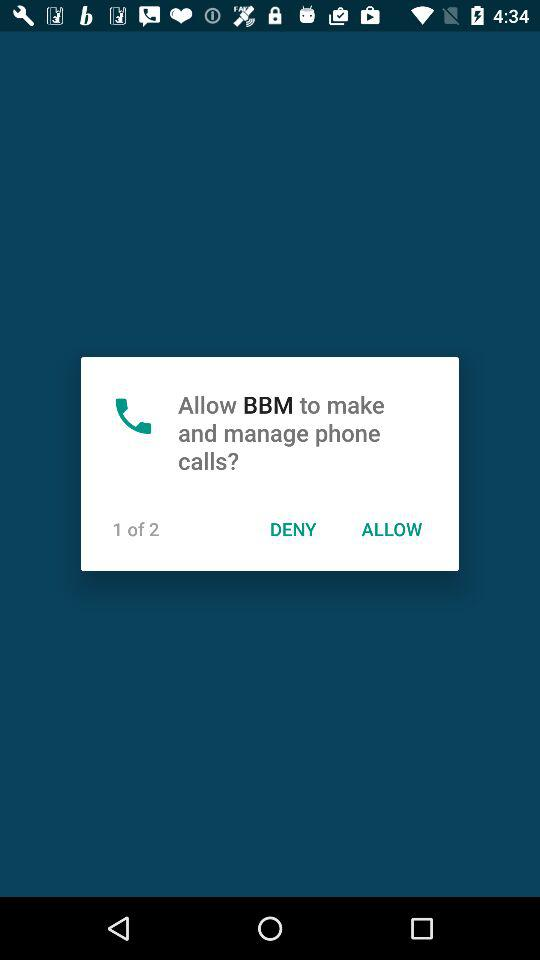What application is asking to make calls? The application is "BBM". 